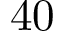<formula> <loc_0><loc_0><loc_500><loc_500>4 0</formula> 